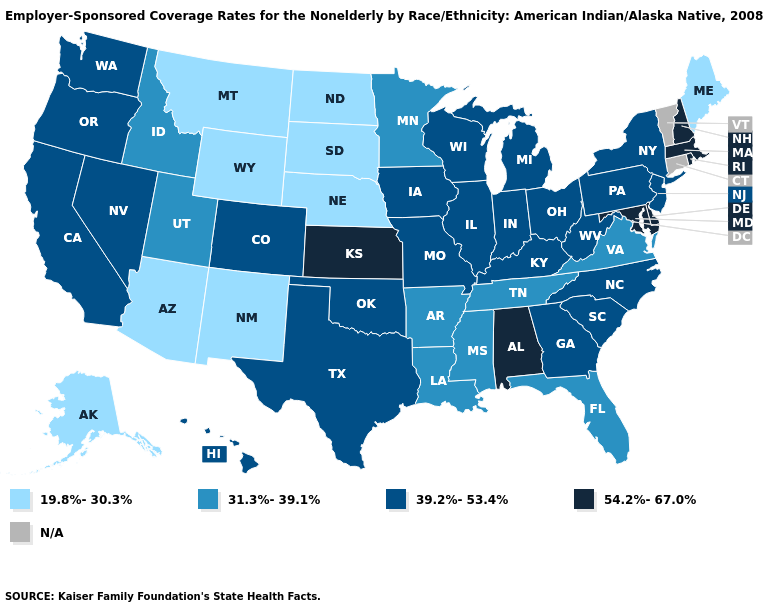What is the highest value in the USA?
Quick response, please. 54.2%-67.0%. What is the value of Michigan?
Answer briefly. 39.2%-53.4%. Among the states that border Minnesota , does North Dakota have the highest value?
Answer briefly. No. Name the states that have a value in the range N/A?
Give a very brief answer. Connecticut, Vermont. Which states hav the highest value in the South?
Be succinct. Alabama, Delaware, Maryland. What is the value of South Dakota?
Give a very brief answer. 19.8%-30.3%. What is the value of Georgia?
Short answer required. 39.2%-53.4%. What is the lowest value in states that border New Jersey?
Concise answer only. 39.2%-53.4%. Which states hav the highest value in the West?
Give a very brief answer. California, Colorado, Hawaii, Nevada, Oregon, Washington. Is the legend a continuous bar?
Write a very short answer. No. What is the value of Maine?
Give a very brief answer. 19.8%-30.3%. What is the value of Utah?
Keep it brief. 31.3%-39.1%. Which states hav the highest value in the West?
Answer briefly. California, Colorado, Hawaii, Nevada, Oregon, Washington. What is the value of Oregon?
Answer briefly. 39.2%-53.4%. Does Hawaii have the highest value in the West?
Short answer required. Yes. 